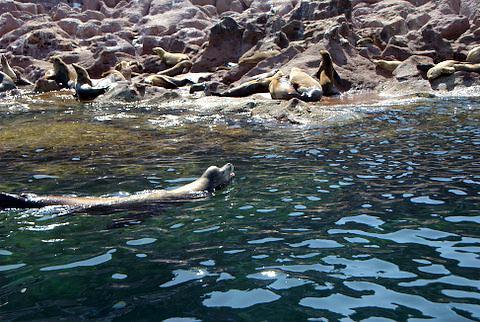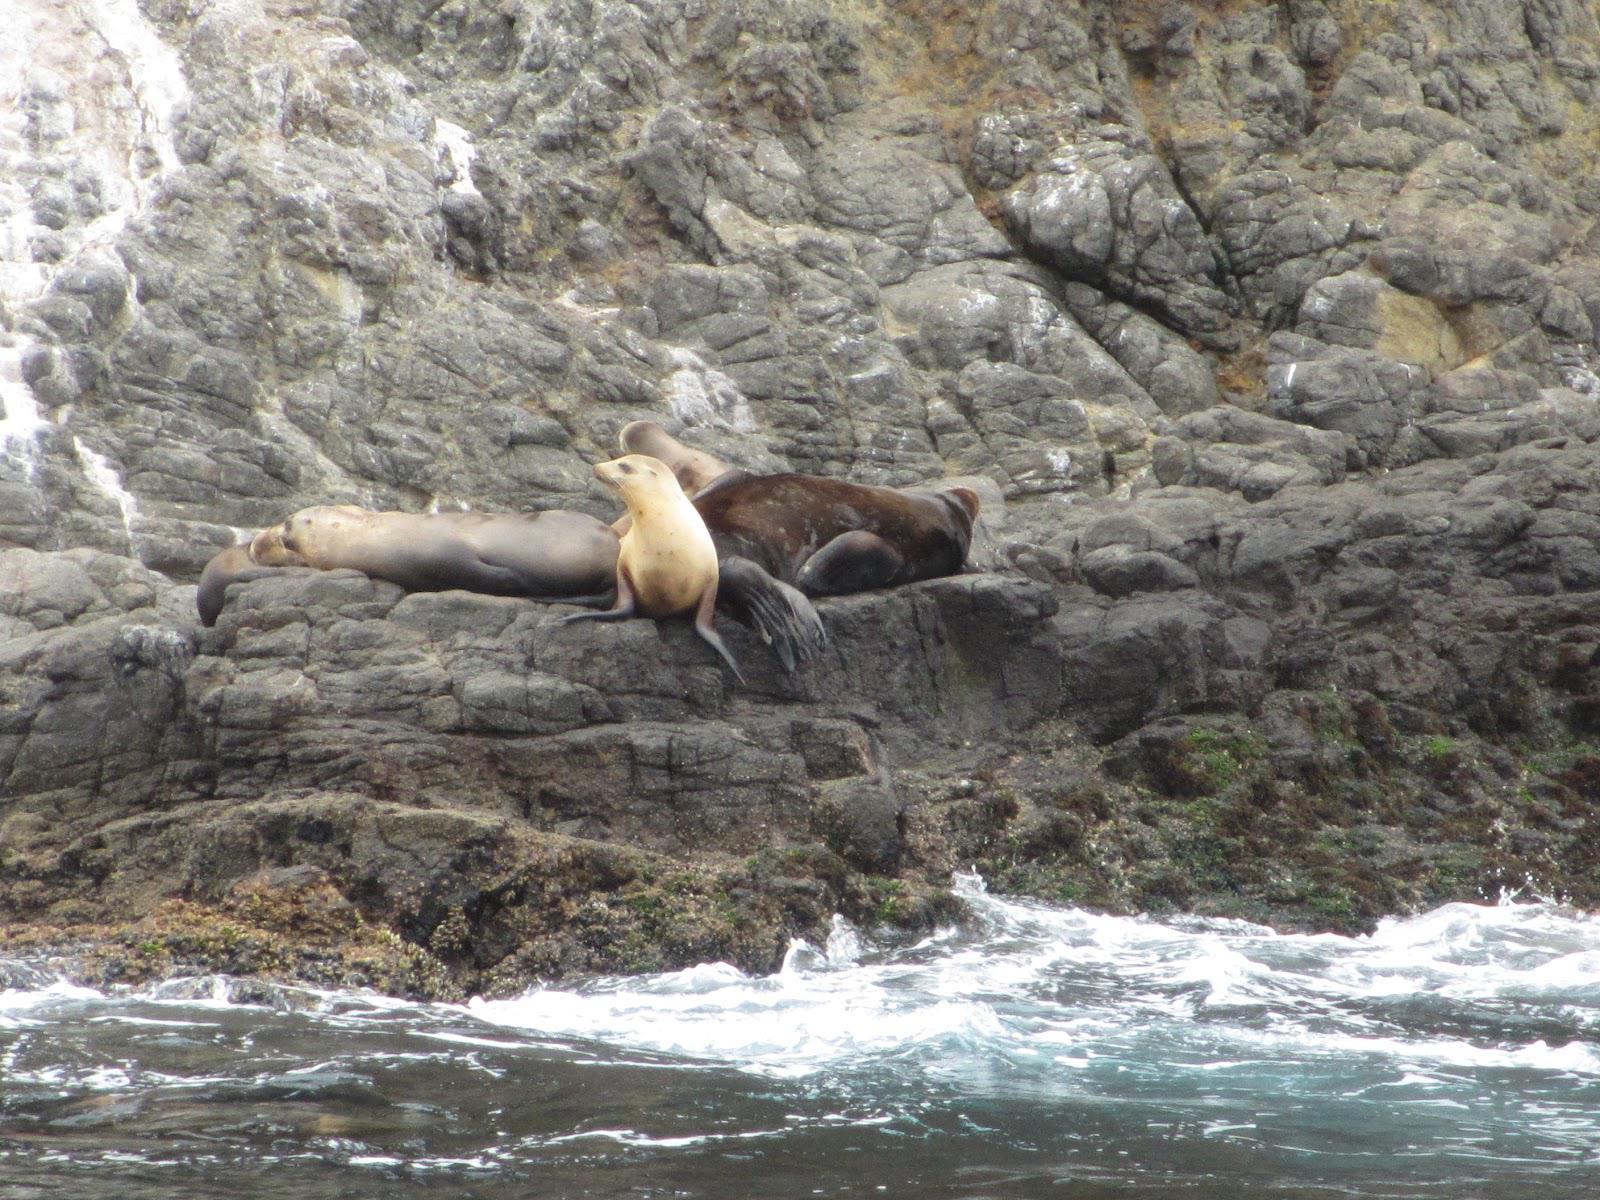The first image is the image on the left, the second image is the image on the right. For the images shown, is this caption "In one image, a seal is in the water." true? Answer yes or no. Yes. The first image is the image on the left, the second image is the image on the right. Assess this claim about the two images: "a single animal is on a rock in the right pic". Correct or not? Answer yes or no. No. 